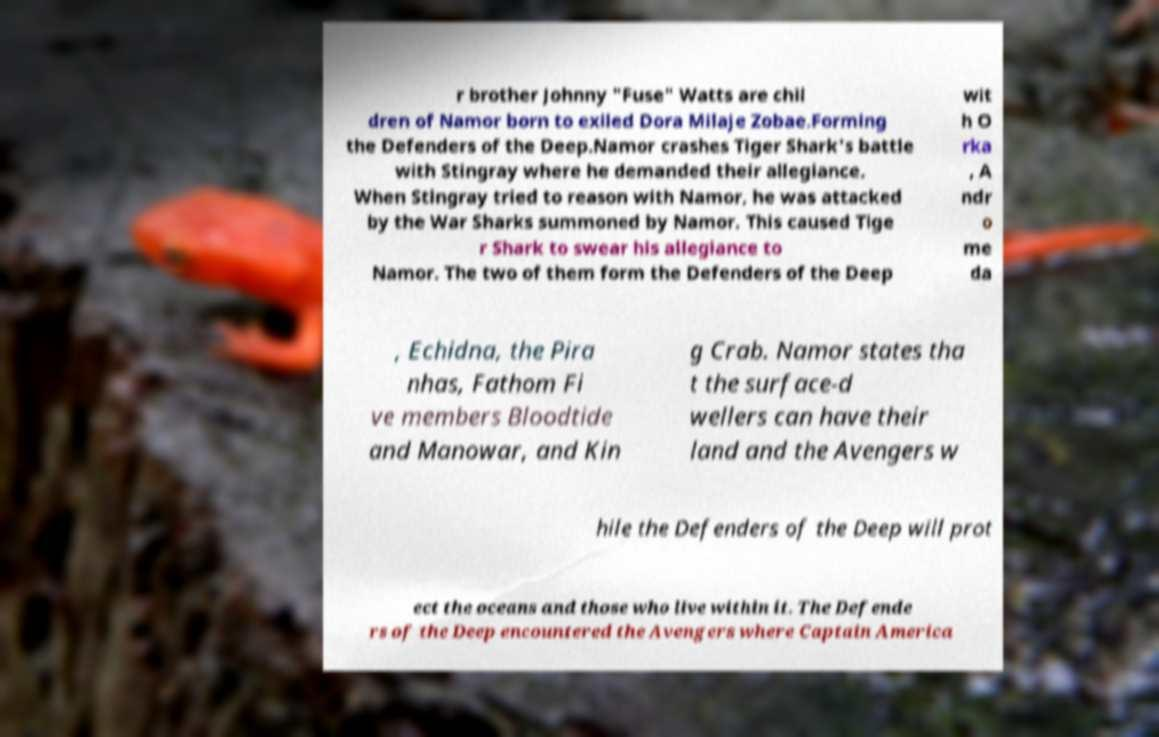There's text embedded in this image that I need extracted. Can you transcribe it verbatim? r brother Johnny "Fuse" Watts are chil dren of Namor born to exiled Dora Milaje Zobae.Forming the Defenders of the Deep.Namor crashes Tiger Shark's battle with Stingray where he demanded their allegiance. When Stingray tried to reason with Namor, he was attacked by the War Sharks summoned by Namor. This caused Tige r Shark to swear his allegiance to Namor. The two of them form the Defenders of the Deep wit h O rka , A ndr o me da , Echidna, the Pira nhas, Fathom Fi ve members Bloodtide and Manowar, and Kin g Crab. Namor states tha t the surface-d wellers can have their land and the Avengers w hile the Defenders of the Deep will prot ect the oceans and those who live within it. The Defende rs of the Deep encountered the Avengers where Captain America 